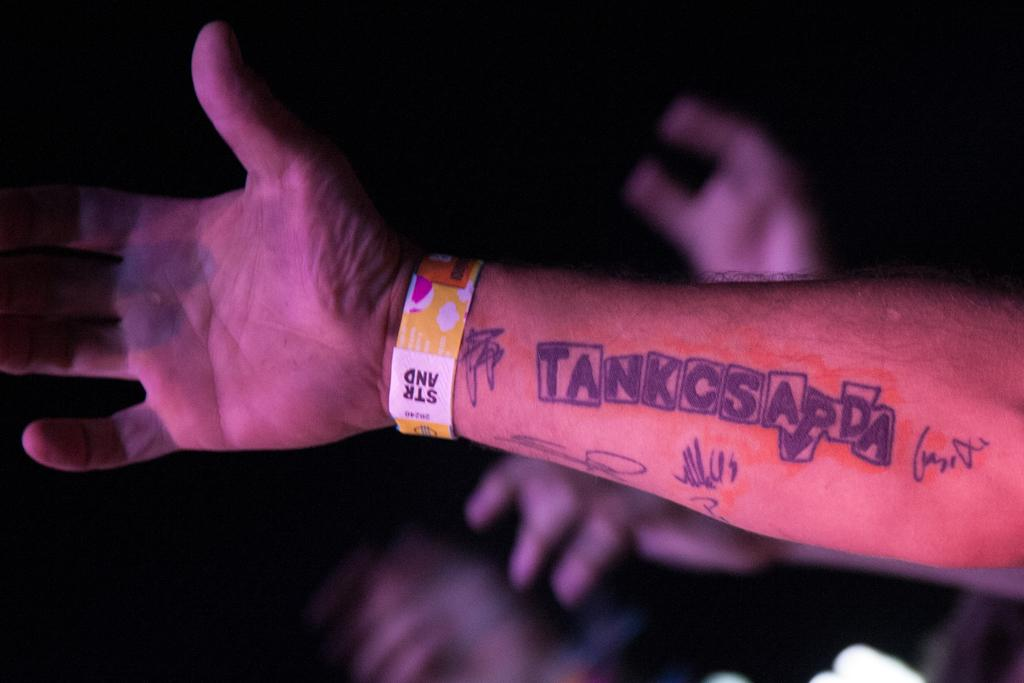What part of a person's body is visible in the image? A person's hand is visible in the image. Are there any distinguishing features on the hand? Yes, there is a tattoo on the hand. Can you describe the background of the image? The background of the image is blurry. Are there any other hands visible in the image? Yes, other persons' hands are visible in the background. What type of skirt is the scarecrow wearing in the image? There is no scarecrow or skirt present in the image. 